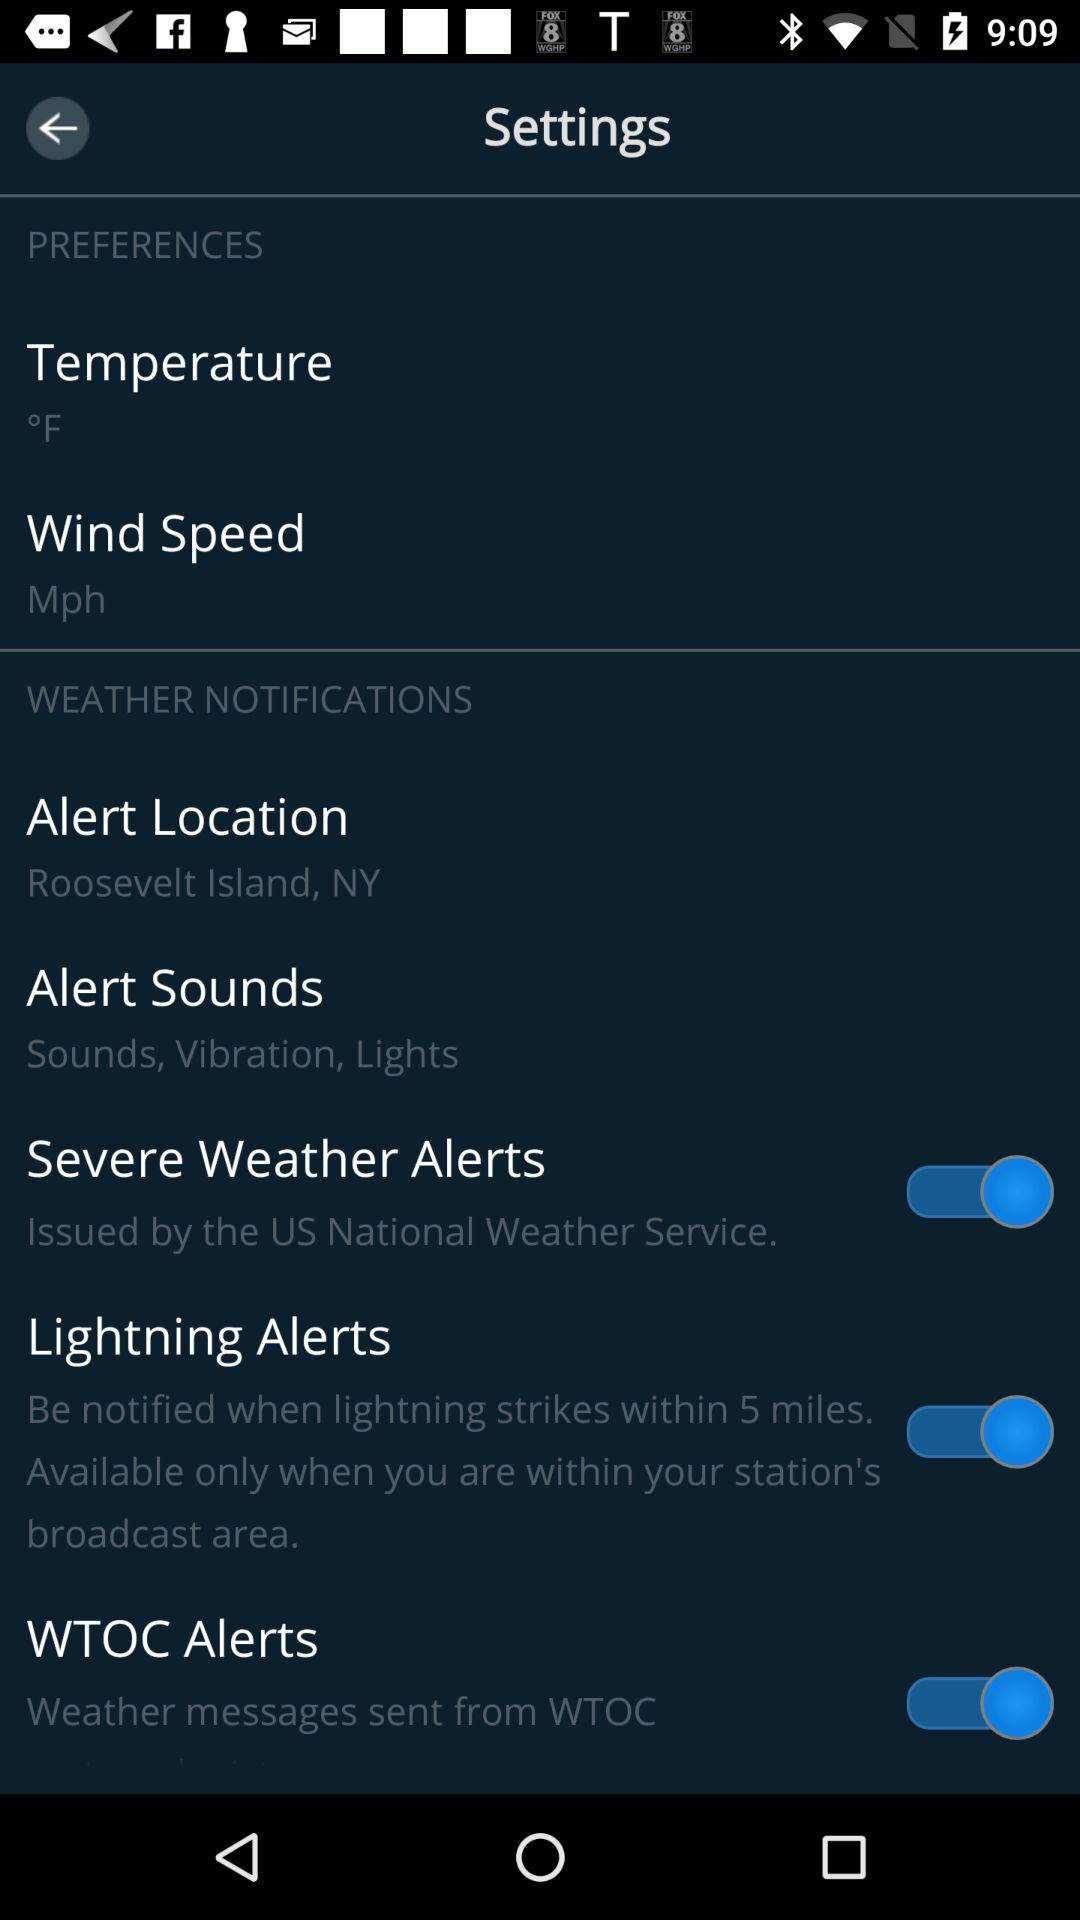What is the status of "Lightning Alerts"? The status is "on". 